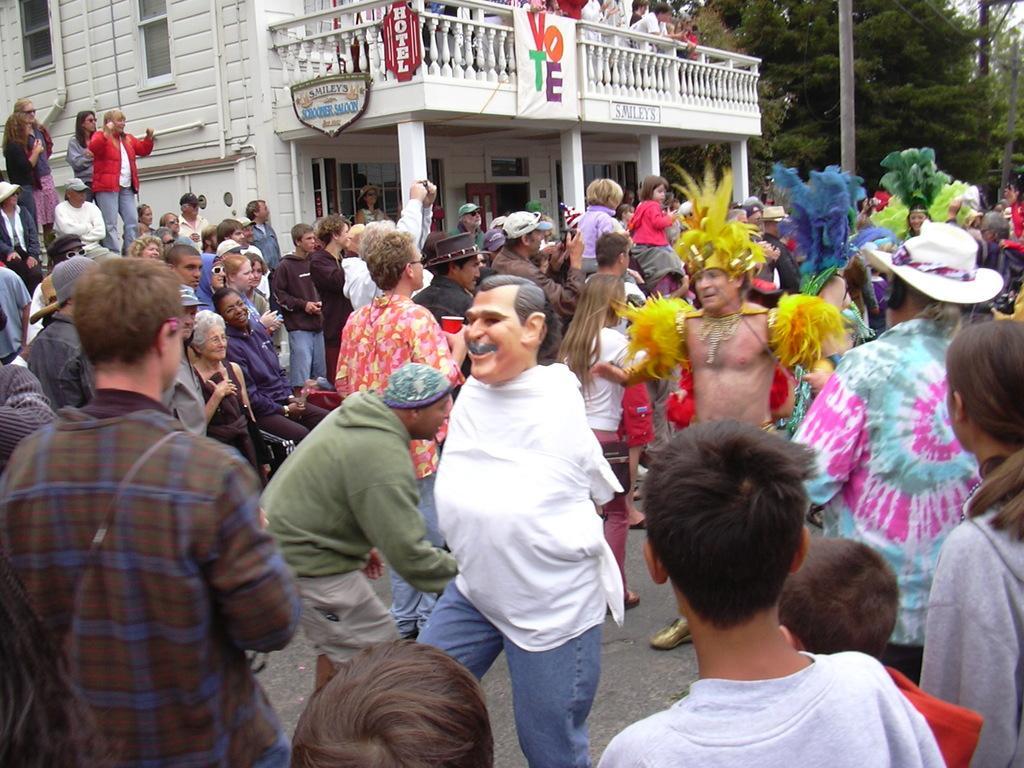Could you give a brief overview of what you see in this image? This image is taken outdoors. At the bottom of the image there is a road. In the middle of the image many people are standing on the road and a few are with different costumes. In the background there is a building with walls, windows, pillars, railings, doors and a balcony and there are a few trees. 